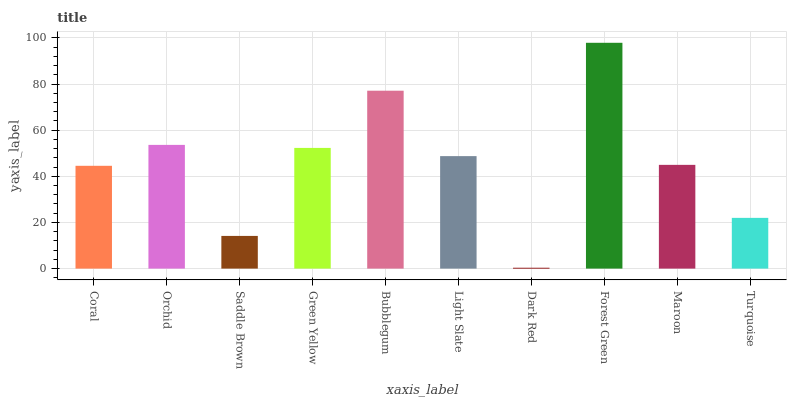Is Dark Red the minimum?
Answer yes or no. Yes. Is Forest Green the maximum?
Answer yes or no. Yes. Is Orchid the minimum?
Answer yes or no. No. Is Orchid the maximum?
Answer yes or no. No. Is Orchid greater than Coral?
Answer yes or no. Yes. Is Coral less than Orchid?
Answer yes or no. Yes. Is Coral greater than Orchid?
Answer yes or no. No. Is Orchid less than Coral?
Answer yes or no. No. Is Light Slate the high median?
Answer yes or no. Yes. Is Maroon the low median?
Answer yes or no. Yes. Is Saddle Brown the high median?
Answer yes or no. No. Is Coral the low median?
Answer yes or no. No. 